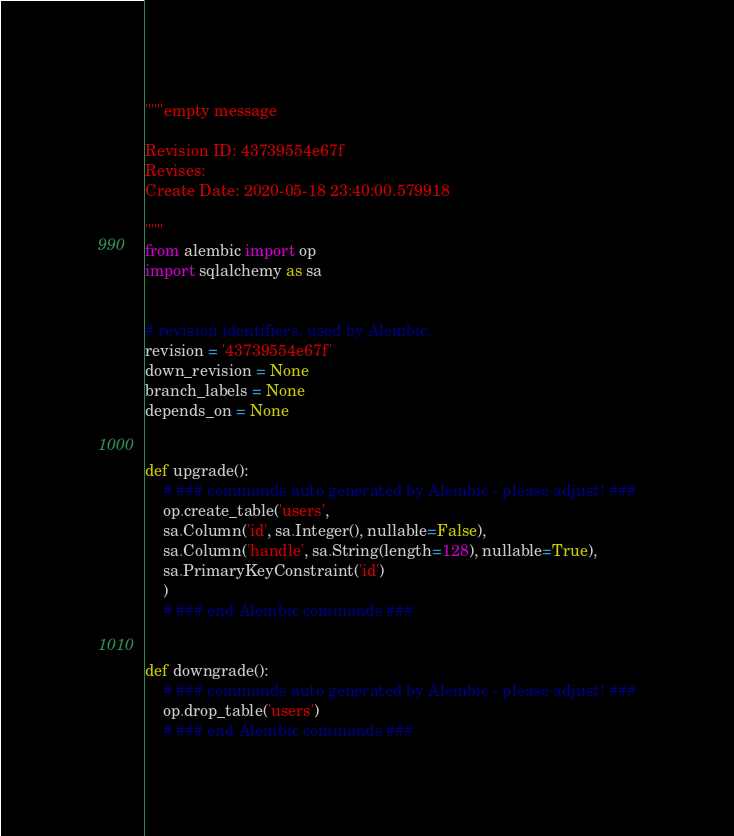<code> <loc_0><loc_0><loc_500><loc_500><_Python_>"""empty message

Revision ID: 43739554e67f
Revises: 
Create Date: 2020-05-18 23:40:00.579918

"""
from alembic import op
import sqlalchemy as sa


# revision identifiers, used by Alembic.
revision = '43739554e67f'
down_revision = None
branch_labels = None
depends_on = None


def upgrade():
    # ### commands auto generated by Alembic - please adjust! ###
    op.create_table('users',
    sa.Column('id', sa.Integer(), nullable=False),
    sa.Column('handle', sa.String(length=128), nullable=True),
    sa.PrimaryKeyConstraint('id')
    )
    # ### end Alembic commands ###


def downgrade():
    # ### commands auto generated by Alembic - please adjust! ###
    op.drop_table('users')
    # ### end Alembic commands ###
</code> 